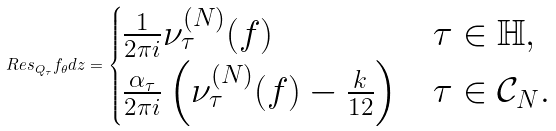Convert formula to latex. <formula><loc_0><loc_0><loc_500><loc_500>R e s _ { Q _ { \tau } } f _ { \theta } d z = \begin{cases} \frac { 1 } { 2 \pi i } \nu _ { \tau } ^ { ( N ) } ( f ) & \tau \in \mathbb { H } , \\ \frac { \alpha _ { \tau } } { 2 \pi i } \left ( \nu _ { \tau } ^ { ( N ) } ( f ) - \frac { k } { 1 2 } \right ) & \tau \in \mathcal { C } _ { N } . \end{cases}</formula> 